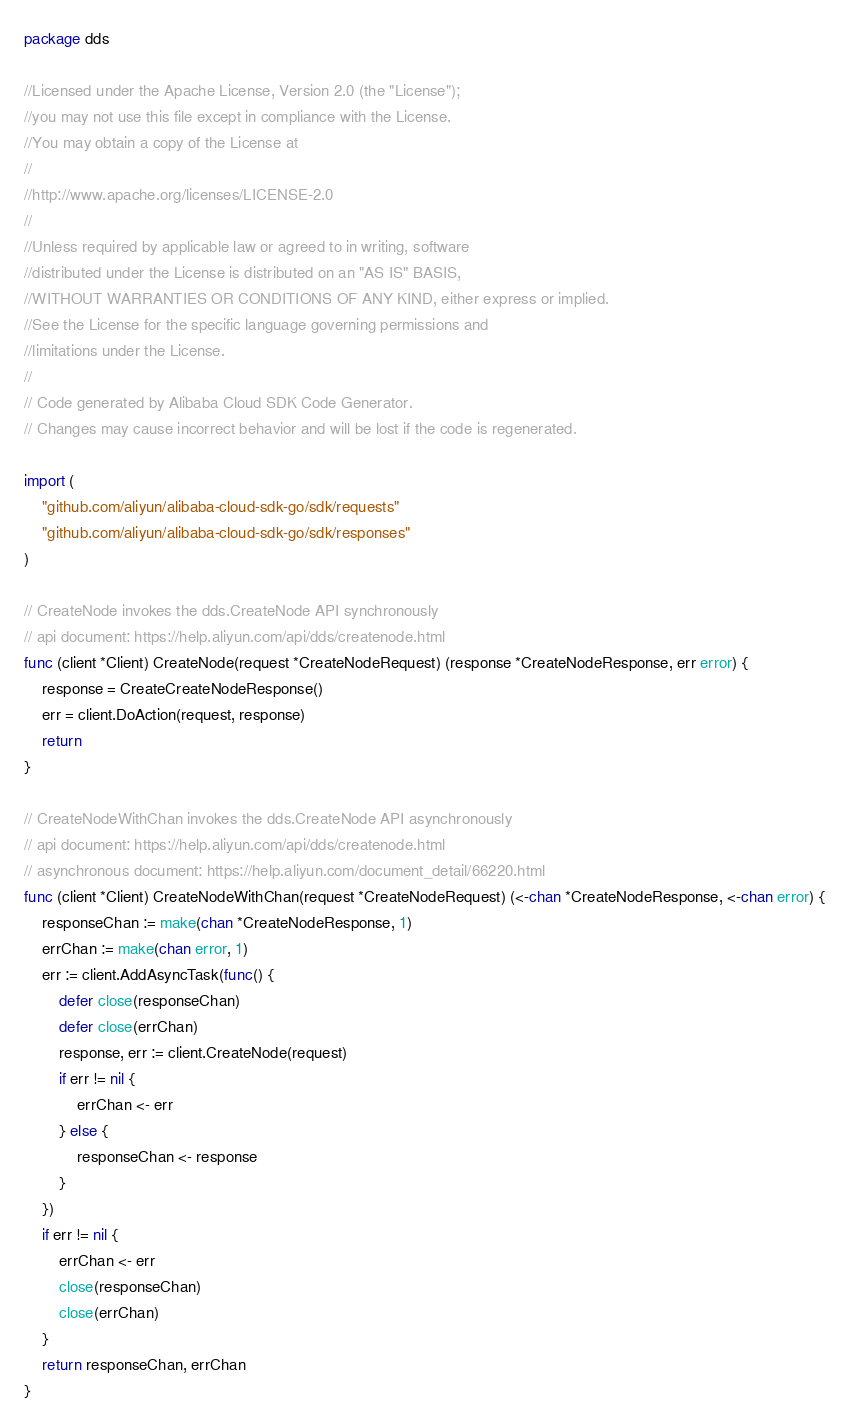<code> <loc_0><loc_0><loc_500><loc_500><_Go_>package dds

//Licensed under the Apache License, Version 2.0 (the "License");
//you may not use this file except in compliance with the License.
//You may obtain a copy of the License at
//
//http://www.apache.org/licenses/LICENSE-2.0
//
//Unless required by applicable law or agreed to in writing, software
//distributed under the License is distributed on an "AS IS" BASIS,
//WITHOUT WARRANTIES OR CONDITIONS OF ANY KIND, either express or implied.
//See the License for the specific language governing permissions and
//limitations under the License.
//
// Code generated by Alibaba Cloud SDK Code Generator.
// Changes may cause incorrect behavior and will be lost if the code is regenerated.

import (
	"github.com/aliyun/alibaba-cloud-sdk-go/sdk/requests"
	"github.com/aliyun/alibaba-cloud-sdk-go/sdk/responses"
)

// CreateNode invokes the dds.CreateNode API synchronously
// api document: https://help.aliyun.com/api/dds/createnode.html
func (client *Client) CreateNode(request *CreateNodeRequest) (response *CreateNodeResponse, err error) {
	response = CreateCreateNodeResponse()
	err = client.DoAction(request, response)
	return
}

// CreateNodeWithChan invokes the dds.CreateNode API asynchronously
// api document: https://help.aliyun.com/api/dds/createnode.html
// asynchronous document: https://help.aliyun.com/document_detail/66220.html
func (client *Client) CreateNodeWithChan(request *CreateNodeRequest) (<-chan *CreateNodeResponse, <-chan error) {
	responseChan := make(chan *CreateNodeResponse, 1)
	errChan := make(chan error, 1)
	err := client.AddAsyncTask(func() {
		defer close(responseChan)
		defer close(errChan)
		response, err := client.CreateNode(request)
		if err != nil {
			errChan <- err
		} else {
			responseChan <- response
		}
	})
	if err != nil {
		errChan <- err
		close(responseChan)
		close(errChan)
	}
	return responseChan, errChan
}
</code> 